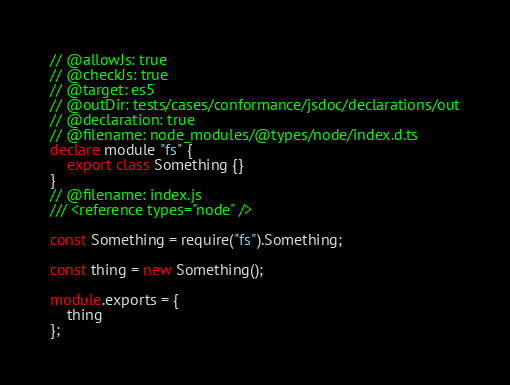Convert code to text. <code><loc_0><loc_0><loc_500><loc_500><_TypeScript_>// @allowJs: true
// @checkJs: true
// @target: es5
// @outDir: tests/cases/conformance/jsdoc/declarations/out
// @declaration: true
// @filename: node_modules/@types/node/index.d.ts
declare module "fs" {
    export class Something {}
}
// @filename: index.js
/// <reference types="node" />

const Something = require("fs").Something;

const thing = new Something();

module.exports = {
    thing
};</code> 